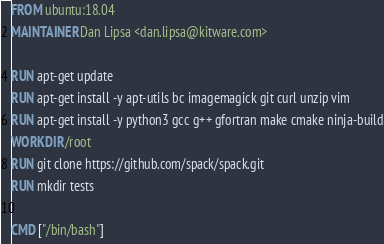Convert code to text. <code><loc_0><loc_0><loc_500><loc_500><_Dockerfile_>FROM ubuntu:18.04
MAINTAINER Dan Lipsa <dan.lipsa@kitware.com>

RUN apt-get update
RUN apt-get install -y apt-utils bc imagemagick git curl unzip vim
RUN apt-get install -y python3 gcc g++ gfortran make cmake ninja-build
WORKDIR /root
RUN git clone https://github.com/spack/spack.git
RUN mkdir tests

CMD ["/bin/bash"]
</code> 